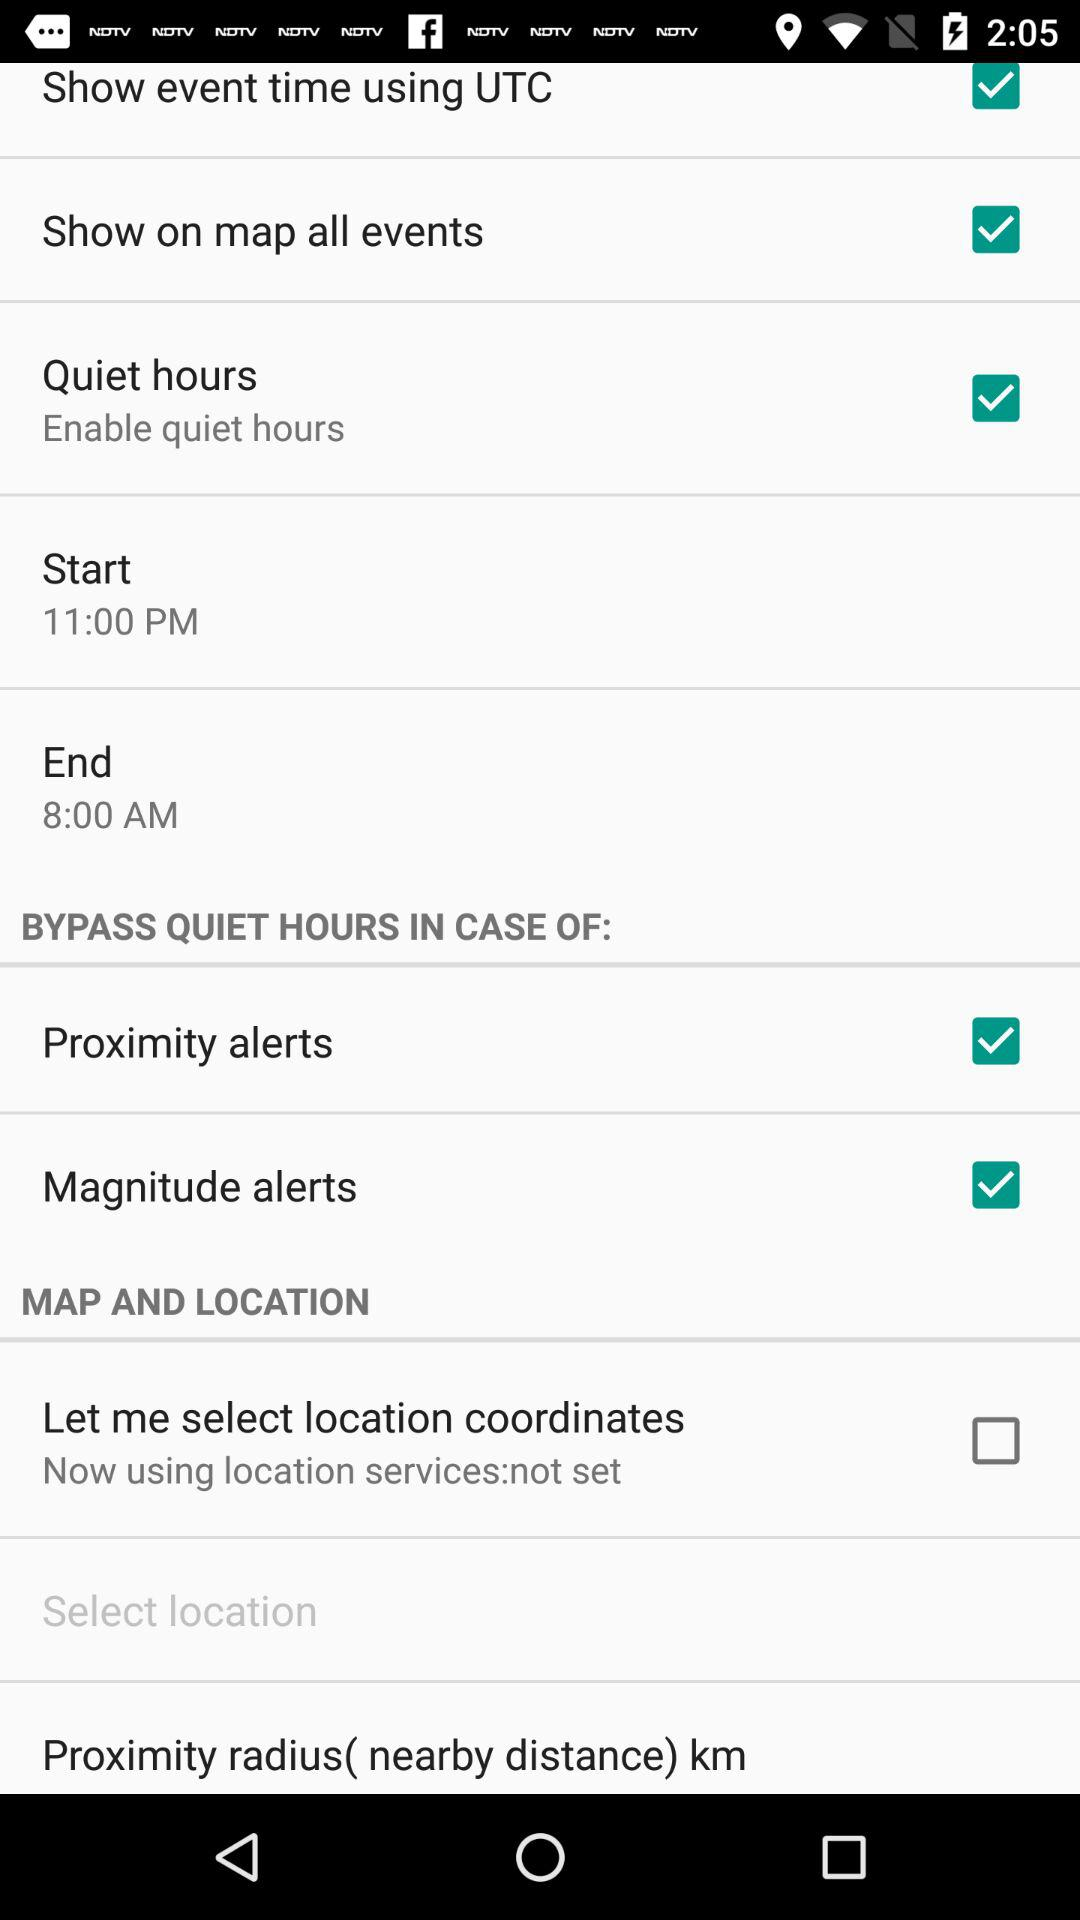What is the starting time? The starting time is 11:00 PM. 